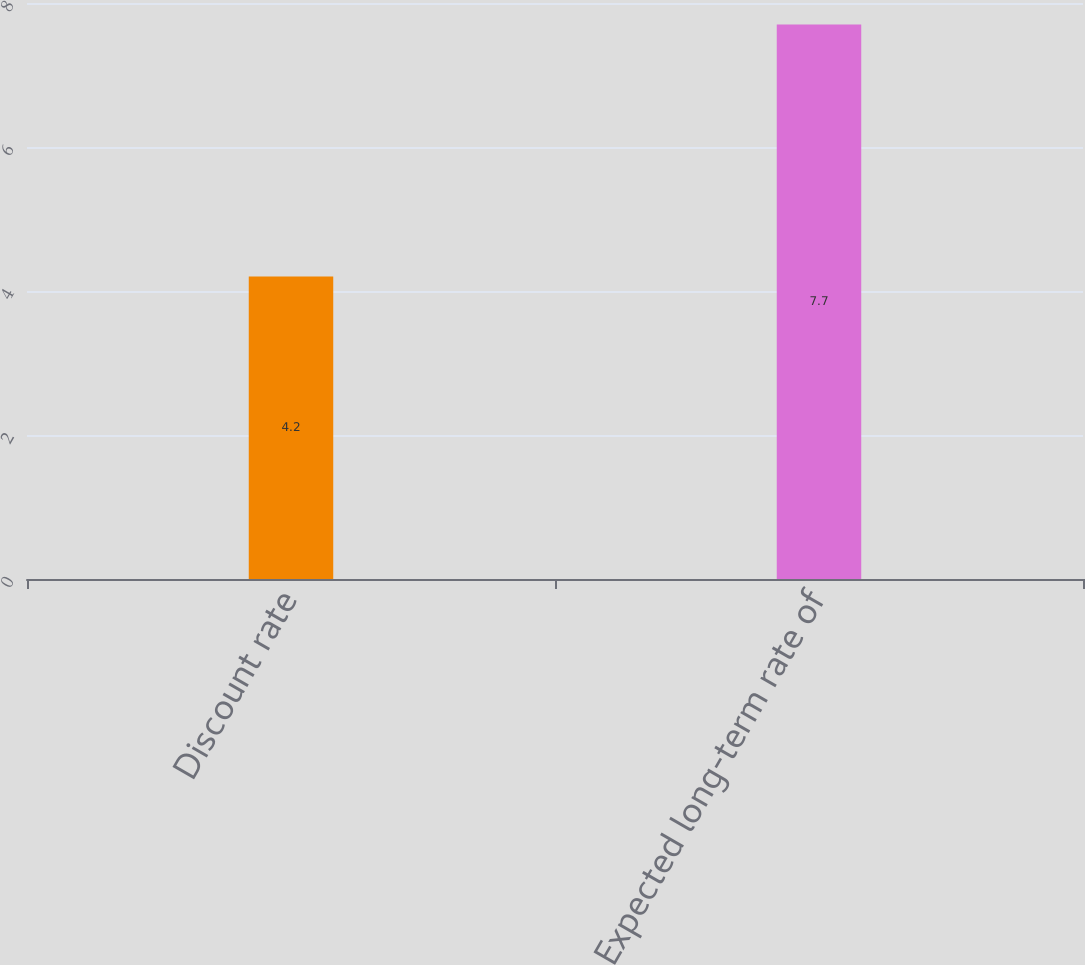Convert chart. <chart><loc_0><loc_0><loc_500><loc_500><bar_chart><fcel>Discount rate<fcel>Expected long-term rate of<nl><fcel>4.2<fcel>7.7<nl></chart> 